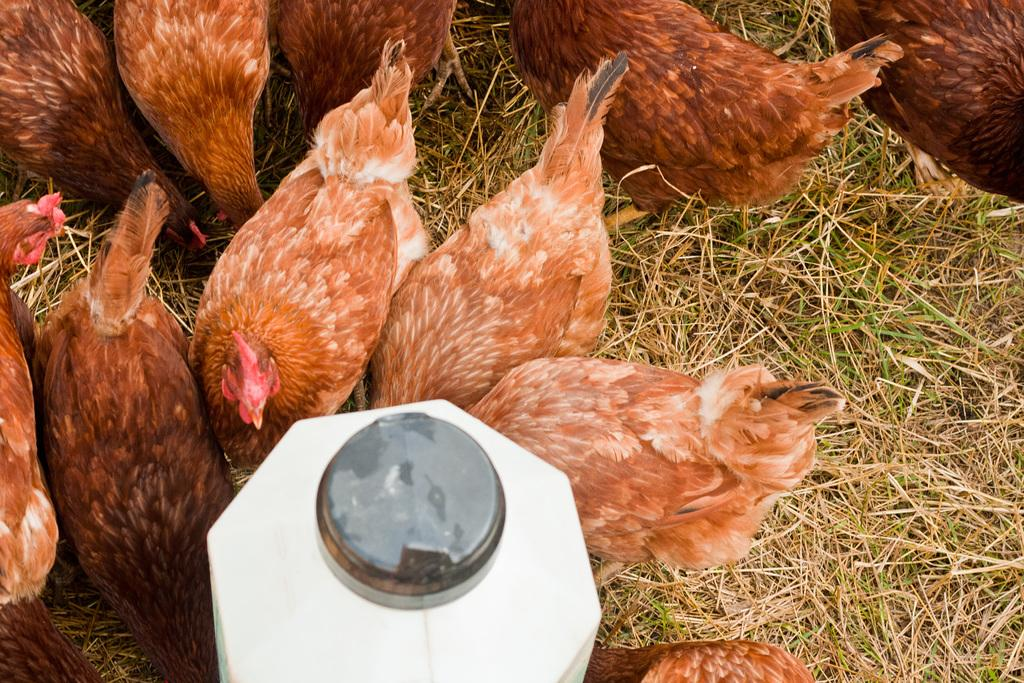What object is located on the left side of the image? There is a white color tin on the left side of the image. What animals can be seen in the image? There are hens visible in the image. Where are the hens located in the image? The hens are on the grass on the ground in the image. Can you describe the background of the image? The hens are visible in the background of the image. How many beads are hanging from the giraffe's neck in the image? There is no giraffe or beads present in the image. 